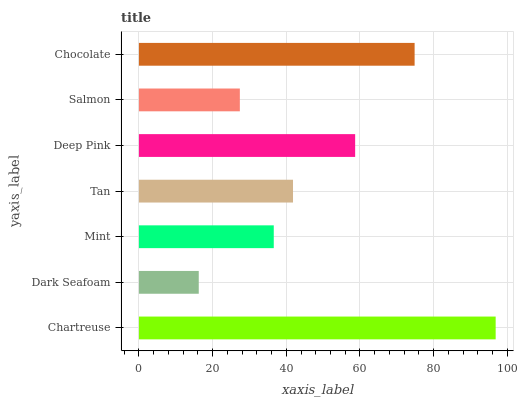Is Dark Seafoam the minimum?
Answer yes or no. Yes. Is Chartreuse the maximum?
Answer yes or no. Yes. Is Mint the minimum?
Answer yes or no. No. Is Mint the maximum?
Answer yes or no. No. Is Mint greater than Dark Seafoam?
Answer yes or no. Yes. Is Dark Seafoam less than Mint?
Answer yes or no. Yes. Is Dark Seafoam greater than Mint?
Answer yes or no. No. Is Mint less than Dark Seafoam?
Answer yes or no. No. Is Tan the high median?
Answer yes or no. Yes. Is Tan the low median?
Answer yes or no. Yes. Is Chocolate the high median?
Answer yes or no. No. Is Salmon the low median?
Answer yes or no. No. 